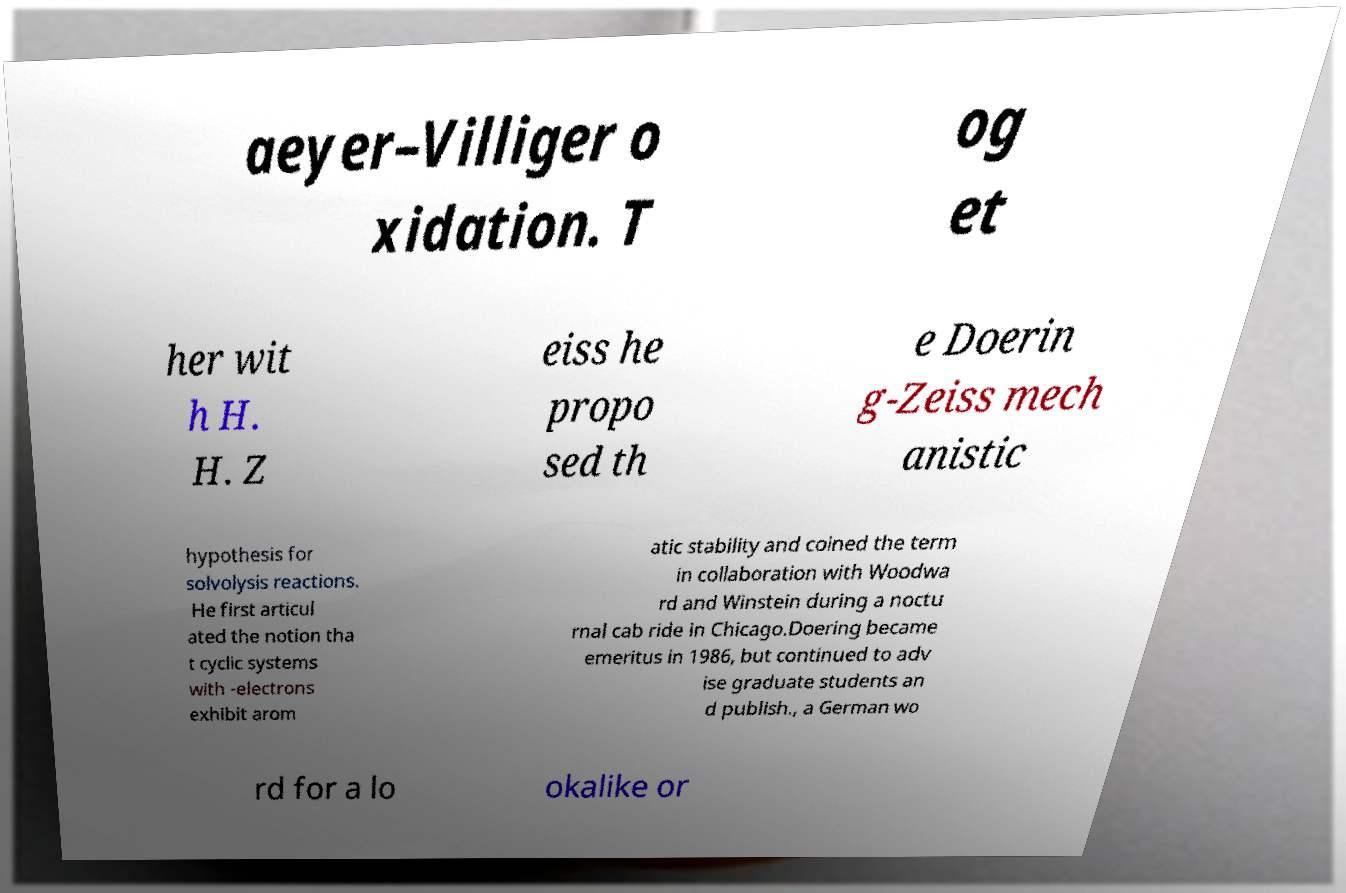For documentation purposes, I need the text within this image transcribed. Could you provide that? aeyer–Villiger o xidation. T og et her wit h H. H. Z eiss he propo sed th e Doerin g-Zeiss mech anistic hypothesis for solvolysis reactions. He first articul ated the notion tha t cyclic systems with -electrons exhibit arom atic stability and coined the term in collaboration with Woodwa rd and Winstein during a noctu rnal cab ride in Chicago.Doering became emeritus in 1986, but continued to adv ise graduate students an d publish., a German wo rd for a lo okalike or 